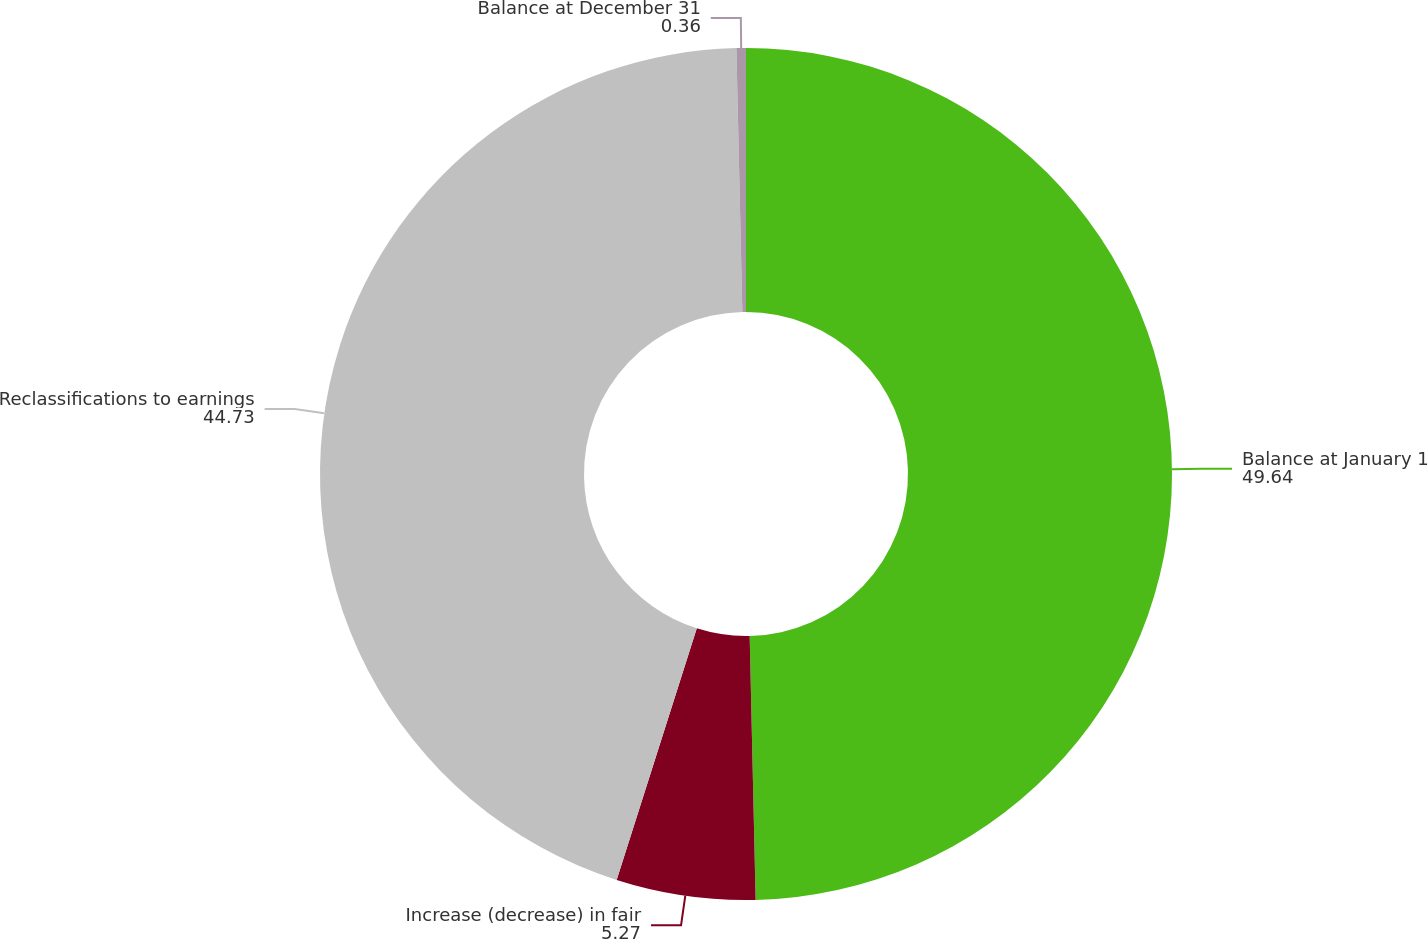Convert chart to OTSL. <chart><loc_0><loc_0><loc_500><loc_500><pie_chart><fcel>Balance at January 1<fcel>Increase (decrease) in fair<fcel>Reclassifications to earnings<fcel>Balance at December 31<nl><fcel>49.64%<fcel>5.27%<fcel>44.73%<fcel>0.36%<nl></chart> 